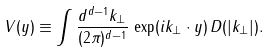Convert formula to latex. <formula><loc_0><loc_0><loc_500><loc_500>V ( y ) \equiv \int \frac { d ^ { d - 1 } k _ { \perp } } { ( 2 \pi ) ^ { d - 1 } } \, \exp ( i k _ { \perp } \cdot y ) \, D ( | k _ { \perp } | ) .</formula> 